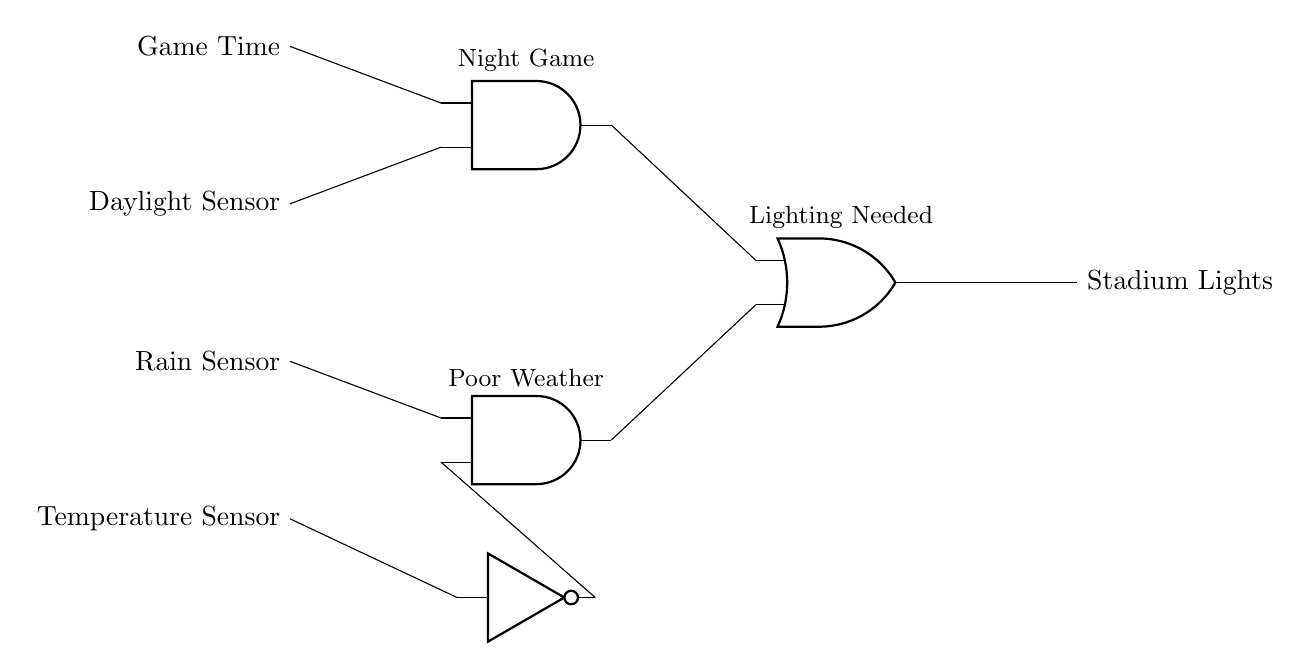What are the inputs to the circuit? The inputs to the circuit are Game Time, Daylight Sensor, Rain Sensor, and Temperature Sensor, as indicated on the left side of the diagram.
Answer: Game Time, Daylight Sensor, Rain Sensor, Temperature Sensor Which gate determines the "Night Game" condition? The AND gate labeled "AND1" is responsible for the "Night Game" condition, which is determined by the Game Time and Daylight Sensor inputs.
Answer: AND1 What is the output of the circuit? The output of the circuit is labeled "Stadium Lights," which indicates the control for lighting based on the input conditions processed through the logic gates.
Answer: Stadium Lights What does the NOT gate indicate in this circuit? The NOT gate labeled "NOT1" inverts the input from the Temperature Sensor, which suggests that if the temperature is undesirable, it will trigger or change the lighting condition based on other inputs.
Answer: Inversion How does the circuit handle "Poor Weather" conditions? The circuit uses the AND gate labeled "AND2," which takes inputs from the Rain Sensor and the inverted output of the Temperature Sensor to determine if lighting is needed due to poor weather conditions.
Answer: AND2 What logic operation does the OR gate perform in this design? The OR gate labeled "OR1" combines the outputs from both AND gates to decide if stadium lights should be turned on based on either the "Night Game" or "Poor Weather" conditions being met.
Answer: OR 